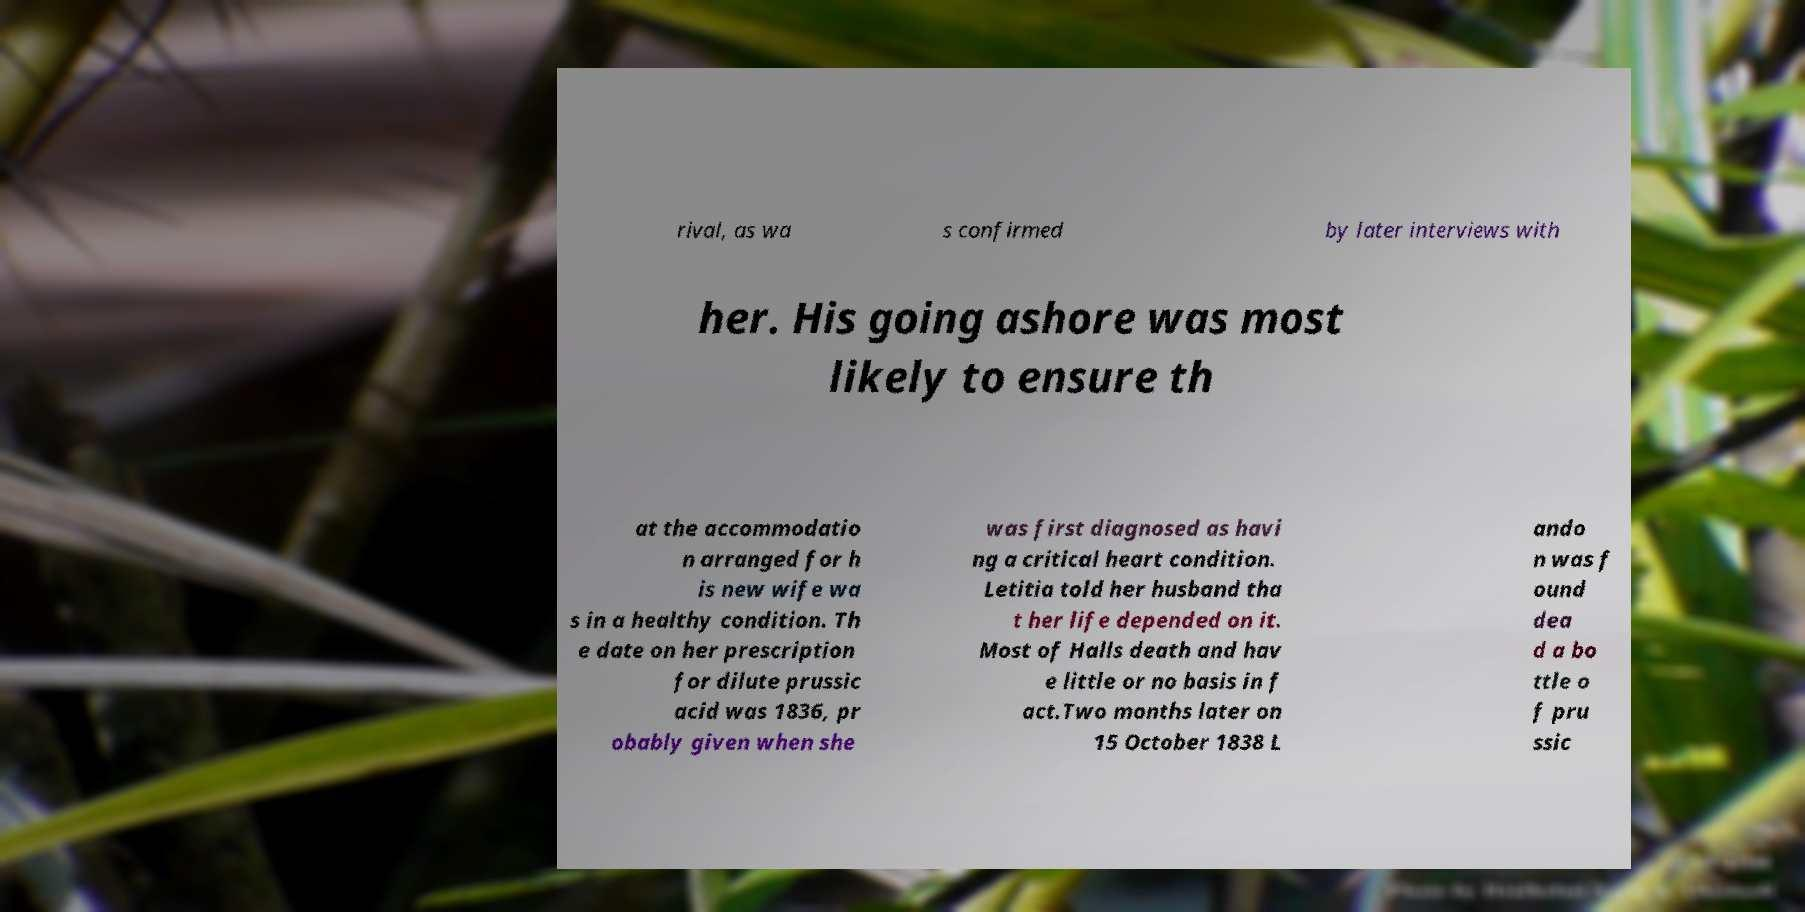Can you accurately transcribe the text from the provided image for me? rival, as wa s confirmed by later interviews with her. His going ashore was most likely to ensure th at the accommodatio n arranged for h is new wife wa s in a healthy condition. Th e date on her prescription for dilute prussic acid was 1836, pr obably given when she was first diagnosed as havi ng a critical heart condition. Letitia told her husband tha t her life depended on it. Most of Halls death and hav e little or no basis in f act.Two months later on 15 October 1838 L ando n was f ound dea d a bo ttle o f pru ssic 